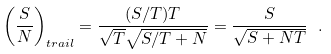Convert formula to latex. <formula><loc_0><loc_0><loc_500><loc_500>\left ( \frac { S } { N } \right ) _ { t r a i l } = \frac { ( S / T ) T } { \sqrt { T } \sqrt { S / T + N } } = \frac { S } { \sqrt { S + N T } } \ .</formula> 